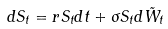Convert formula to latex. <formula><loc_0><loc_0><loc_500><loc_500>d S _ { t } = r S _ { t } d t + \sigma S _ { t } d \tilde { W } _ { t }</formula> 